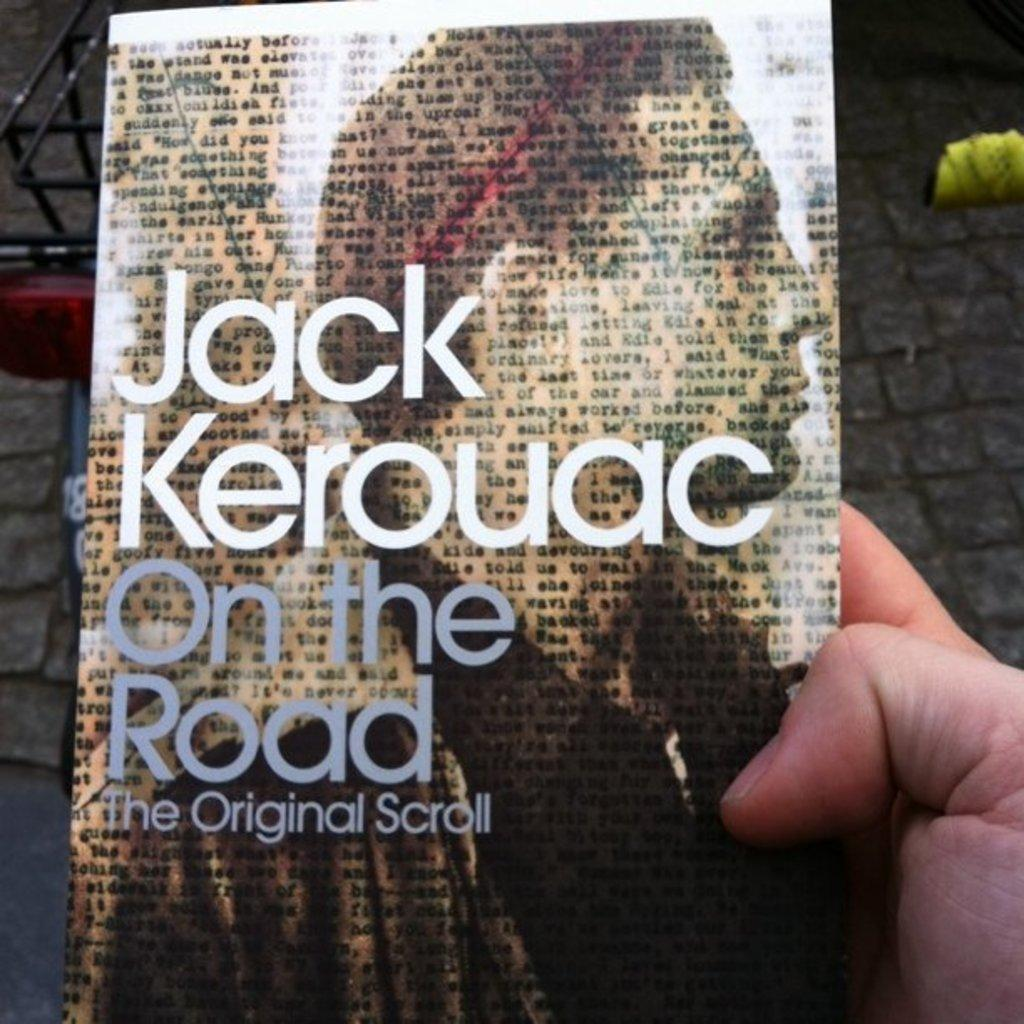What object is in the middle of the image? There is a book in the middle of the image. Where is the hand located in relation to the book? The hand is on the right side of the book. What is depicted on the book cover? There is a man depicted on the book cover. What power does the man depicted on the book cover possess? There is no information about the man's power in the image. The image only shows a book with a man on the cover and a hand holding it. 